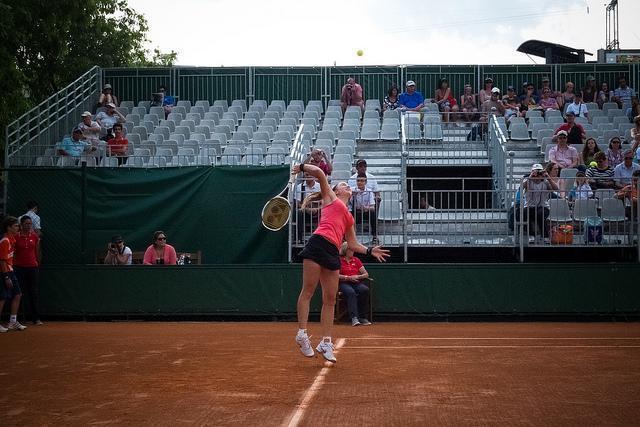What type of shot is the woman about to hit?
Answer the question by selecting the correct answer among the 4 following choices.
Options: Serve, backhand, forehand, slice. Serve. 